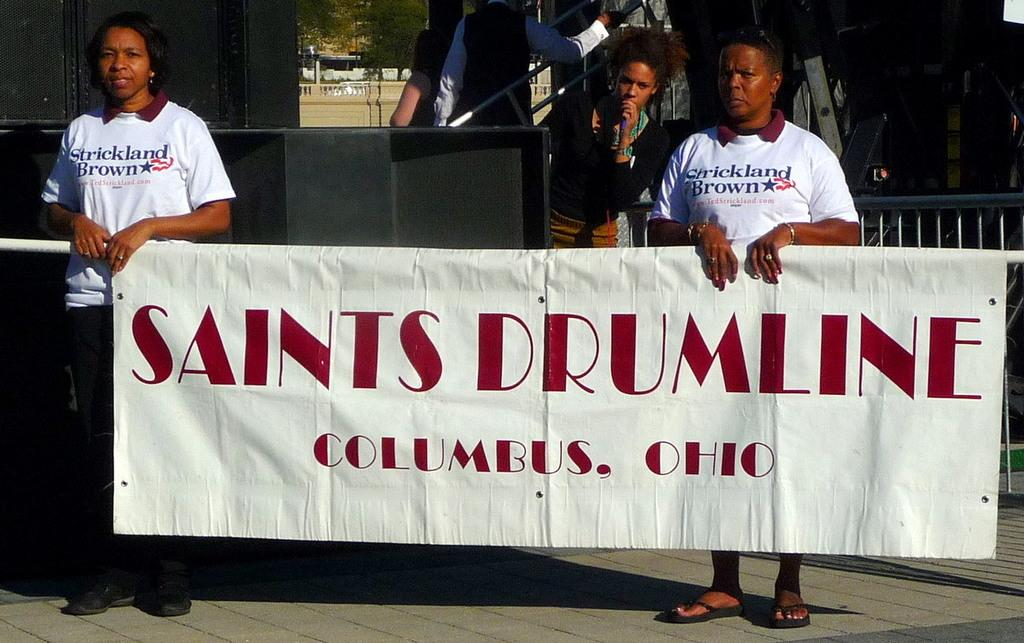Provide a one-sentence caption for the provided image. Two people in white shirts are holding a Saints Drumline banner. 